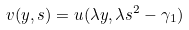<formula> <loc_0><loc_0><loc_500><loc_500>v ( y , s ) = u ( \lambda y , \lambda s ^ { 2 } - \gamma _ { 1 } )</formula> 